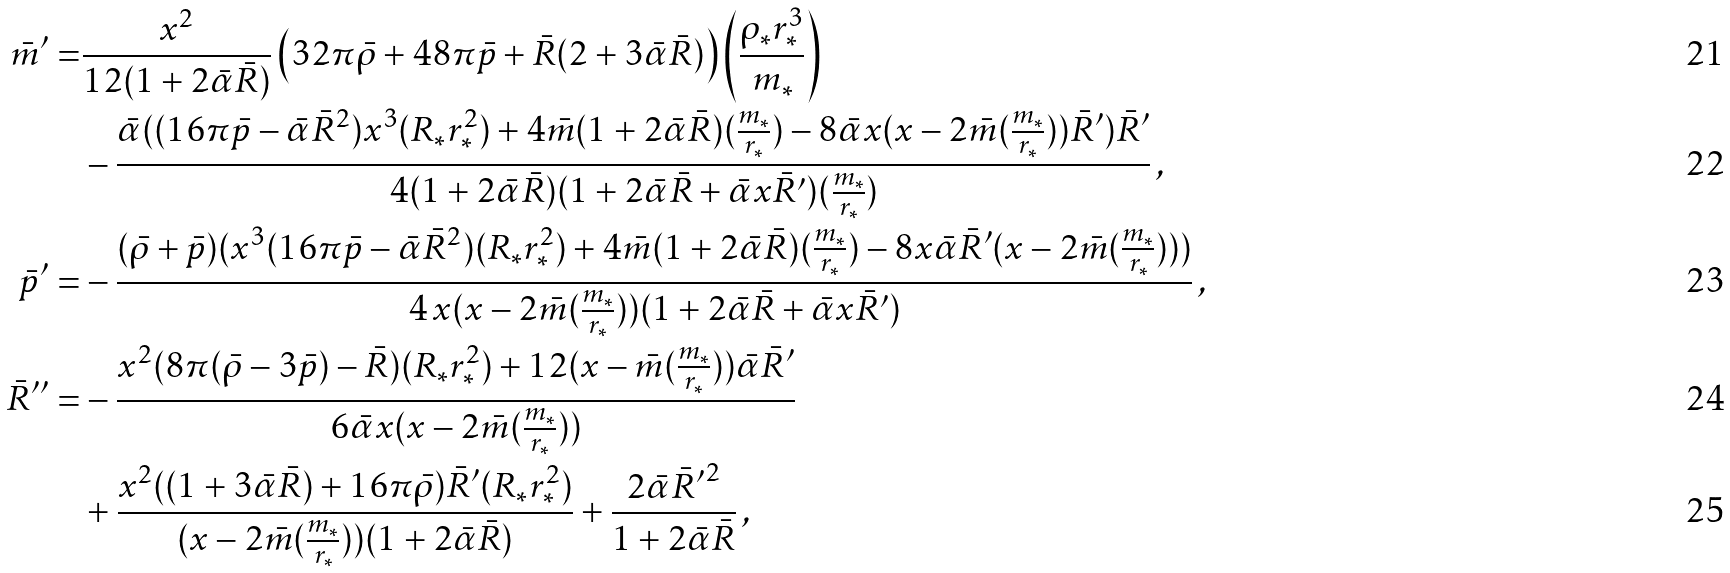<formula> <loc_0><loc_0><loc_500><loc_500>\bar { m } { ^ { \prime } } = & \frac { x ^ { 2 } } { 1 2 ( 1 + 2 \bar { \alpha } \bar { R } ) } \left ( 3 2 \pi \bar { \rho } + 4 8 \pi \bar { p } + \bar { R } ( 2 + 3 \bar { \alpha } \bar { R } ) \right ) \left ( \frac { \rho _ { * } r _ { * } ^ { 3 } } { m _ { * } } \right ) \\ & - \frac { \bar { \alpha } ( ( 1 6 \pi \bar { p } - \bar { \alpha } \bar { R } ^ { 2 } ) x ^ { 3 } ( R _ { * } r _ { * } ^ { 2 } ) + 4 \bar { m } ( 1 + 2 \bar { \alpha } \bar { R } ) ( \frac { m _ { * } } { r _ { * } } ) - 8 \bar { \alpha } x ( x - 2 \bar { m } ( \frac { m _ { * } } { r _ { * } } ) ) \bar { R } { ^ { \prime } } ) \bar { R } { ^ { \prime } } } { 4 ( 1 + 2 \bar { \alpha } \bar { R } ) ( 1 + 2 \bar { \alpha } \bar { R } + \bar { \alpha } x \bar { R } ^ { \prime } ) ( \frac { m _ { * } } { r _ { * } } ) } \, , \\ \bar { p } { ^ { \prime } } = & - \frac { ( \bar { \rho } + \bar { p } ) ( x ^ { 3 } ( 1 6 \pi \bar { p } - \bar { \alpha } \bar { R } ^ { 2 } ) ( R _ { * } r _ { * } ^ { 2 } ) + 4 \bar { m } ( 1 + 2 \bar { \alpha } \bar { R } ) ( \frac { m _ { * } } { r _ { * } } ) - 8 x \bar { \alpha } \bar { R } { ^ { \prime } } ( x - 2 \bar { m } ( \frac { m _ { * } } { r _ { * } } ) ) ) } { 4 \, x ( x - 2 \bar { m } ( \frac { m _ { * } } { r _ { * } } ) ) ( 1 + 2 \bar { \alpha } \bar { R } + \bar { \alpha } x \bar { R } ^ { \prime } ) } \, , \\ \bar { R } { ^ { \prime \prime } } = & - \frac { x ^ { 2 } ( 8 \pi ( \bar { \rho } - 3 \bar { p } ) - \bar { R } ) ( R _ { * } r _ { * } ^ { 2 } ) + 1 2 ( x - \bar { m } ( \frac { m _ { * } } { r _ { * } } ) ) \bar { \alpha } \bar { R } { ^ { \prime } } } { 6 \bar { \alpha } x ( x - 2 \bar { m } ( \frac { m _ { * } } { r _ { * } } ) ) } \, \\ & + \frac { x ^ { 2 } ( ( 1 + 3 \bar { \alpha } \bar { R } ) + 1 6 \pi \bar { \rho } ) \bar { R } ^ { \prime } ( R _ { * } r _ { * } ^ { 2 } ) } { ( x - 2 \bar { m } ( \frac { m _ { * } } { r _ { * } } ) ) ( 1 + 2 \bar { \alpha } \bar { R } ) } + \frac { 2 \bar { \alpha } \bar { R } { ^ { \prime } } ^ { 2 } } { 1 + 2 \bar { \alpha } \bar { R } } \, ,</formula> 